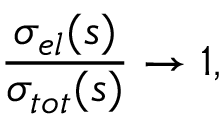<formula> <loc_0><loc_0><loc_500><loc_500>\frac { \sigma _ { e l } ( s ) } { \sigma _ { t o t } ( s ) } \rightarrow 1 ,</formula> 